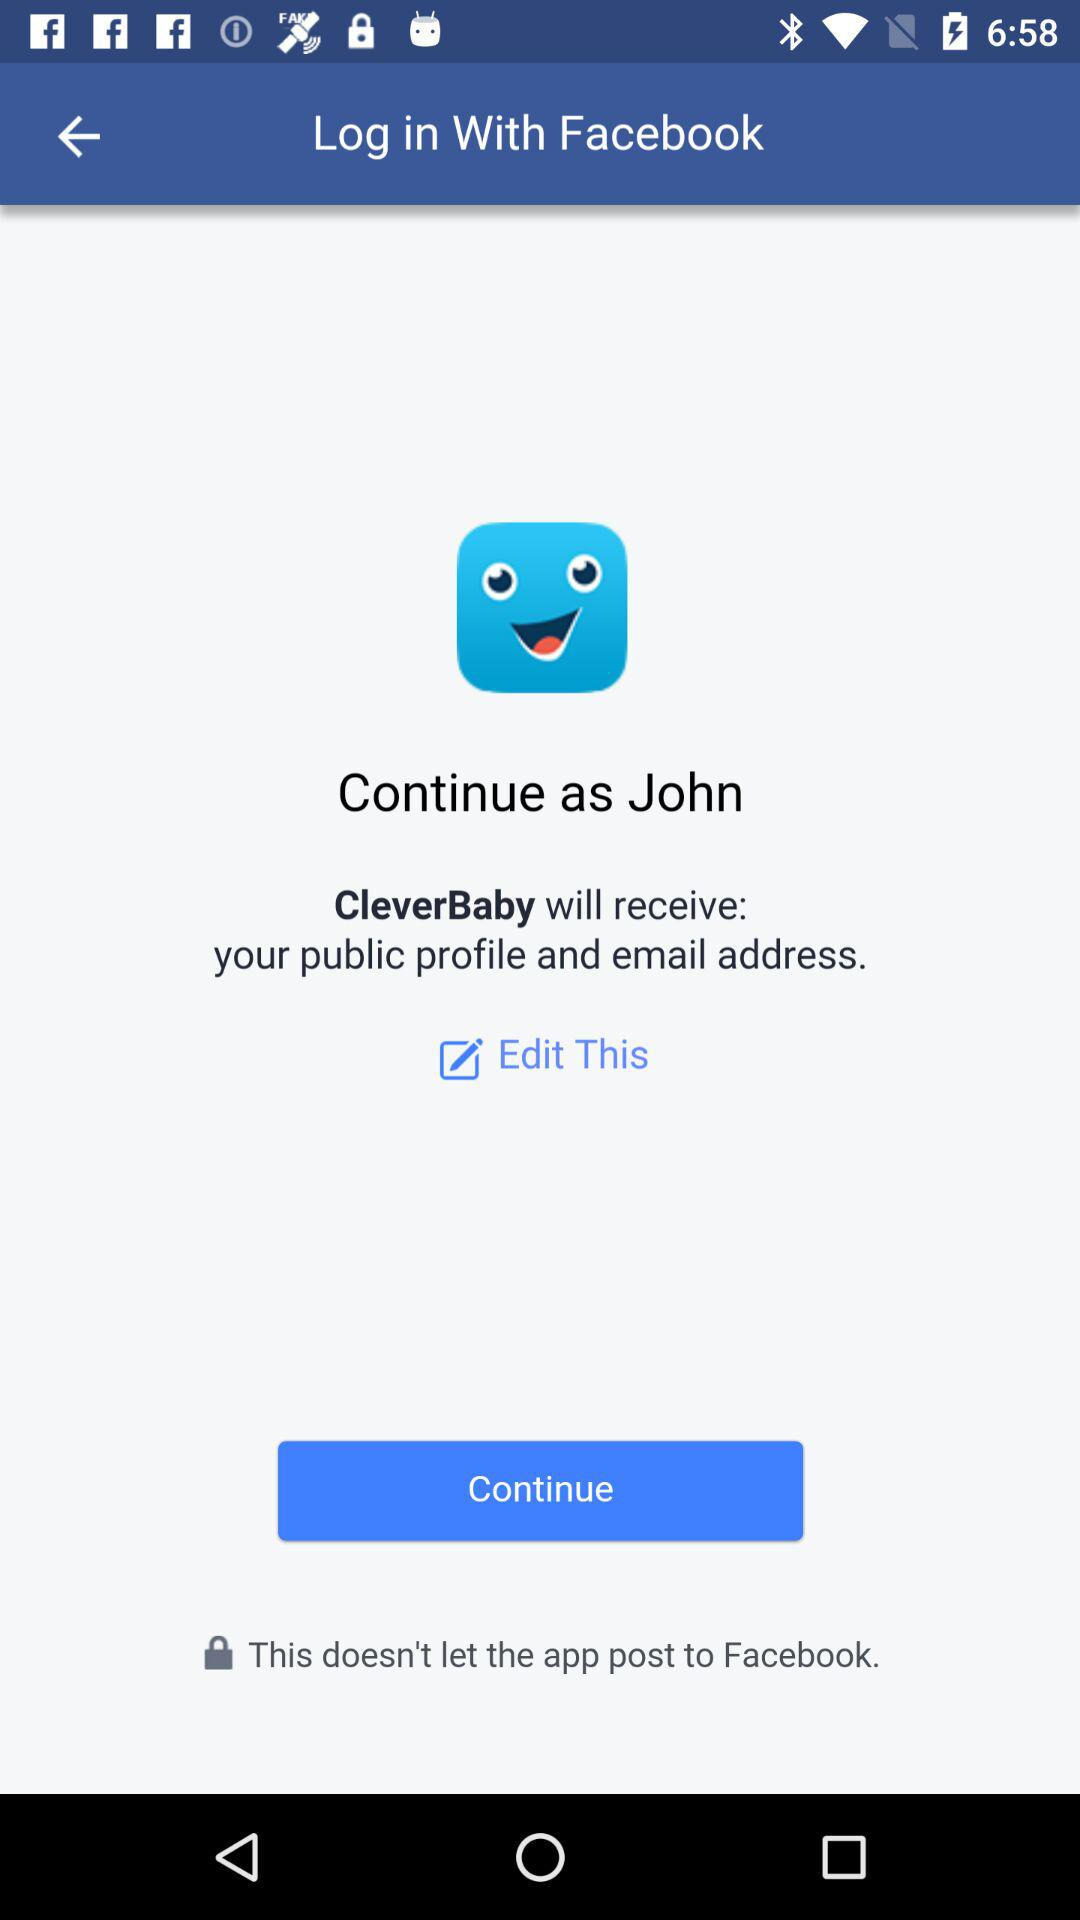What is the application name? The application name is "Facebook". 